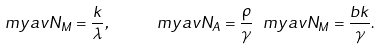<formula> <loc_0><loc_0><loc_500><loc_500>\ m y a v { N _ { M } } = \frac { k } { \lambda } , \quad \ m y a v { N _ { A } } = \frac { \rho } { \gamma } \ m y a v { N _ { M } } = \frac { b k } { \gamma } .</formula> 